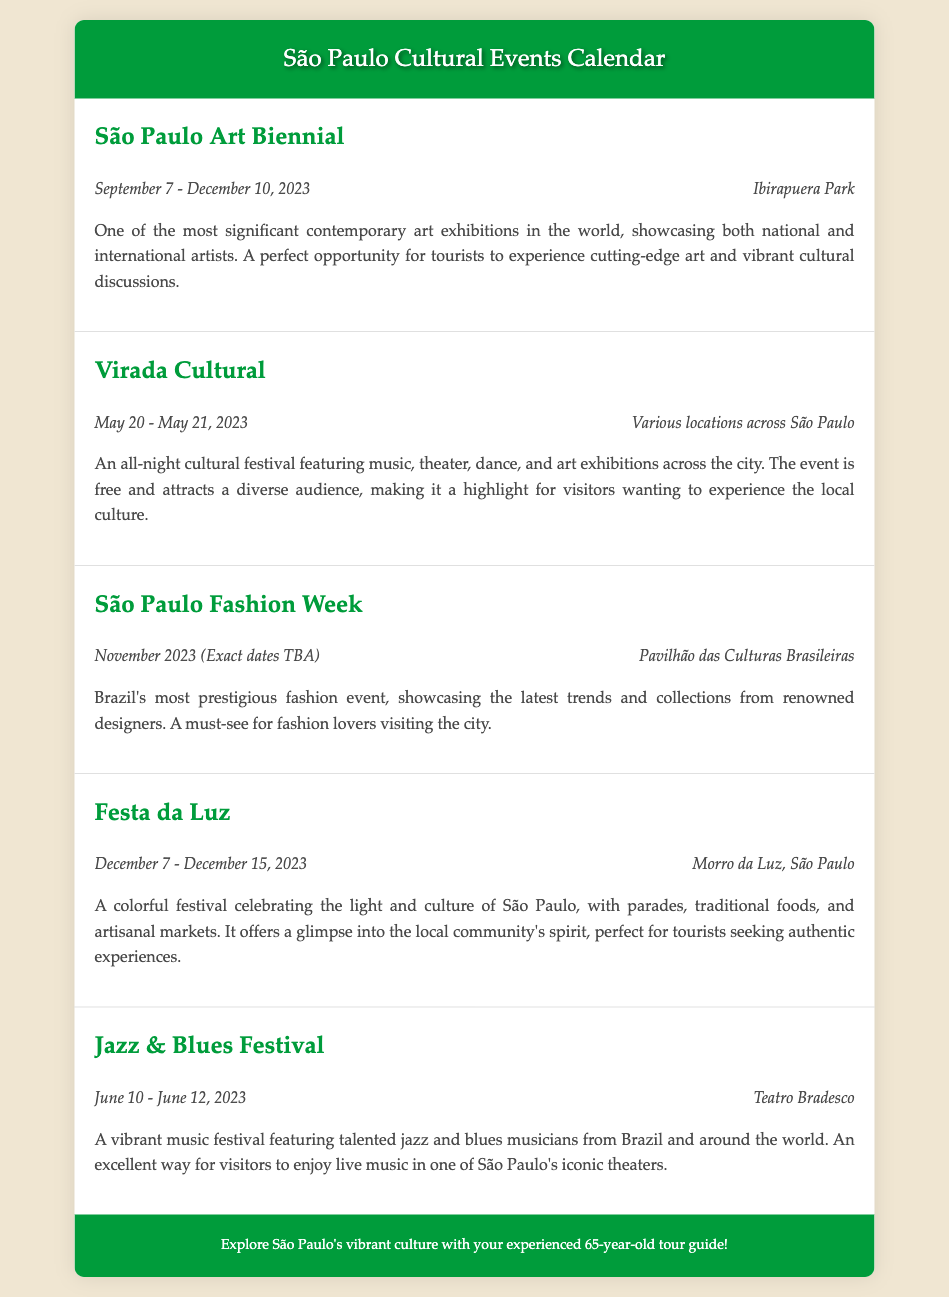What is the main event taking place from September 7 to December 10, 2023? The document states that the São Paulo Art Biennial is the main event during this period, showcasing contemporary art from national and international artists.
Answer: São Paulo Art Biennial Where will the São Paulo Fashion Week be held? According to the document, the São Paulo Fashion Week will take place at the Pavilhão das Culturas Brasileiras.
Answer: Pavilhão das Culturas Brasileiras What dates does the Festa da Luz festival occur? The document specifies that the Festa da Luz will take place from December 7 to December 15, 2023.
Answer: December 7 - December 15, 2023 What type of performances are featured in Virada Cultural? The document mentions that the Virada Cultural features music, theater, dance, and art exhibitions, making it an all-night cultural festival.
Answer: Music, theater, dance, and art exhibitions How long does the Jazz & Blues Festival last? The document indicates that the Jazz & Blues Festival is scheduled for three days, from June 10 to June 12, 2023.
Answer: Three days What is the highlight of the São Paulo Art Biennial? The document highlights that the São Paulo Art Biennial is one of the most significant contemporary art exhibitions in the world, featuring national and international artists.
Answer: Significant contemporary art exhibition What types of events does Festa da Luz include? According to the document, the Festa da Luz includes parades, traditional foods, and artisanal markets, celebrating light and culture.
Answer: Parades, traditional foods, and artisanal markets What is unique about the Virada Cultural? The document states that Virada Cultural is an all-night cultural festival that is free and attracts a diverse audience, making it a highlight for visitors.
Answer: All-night cultural festival, free, diverse audience 